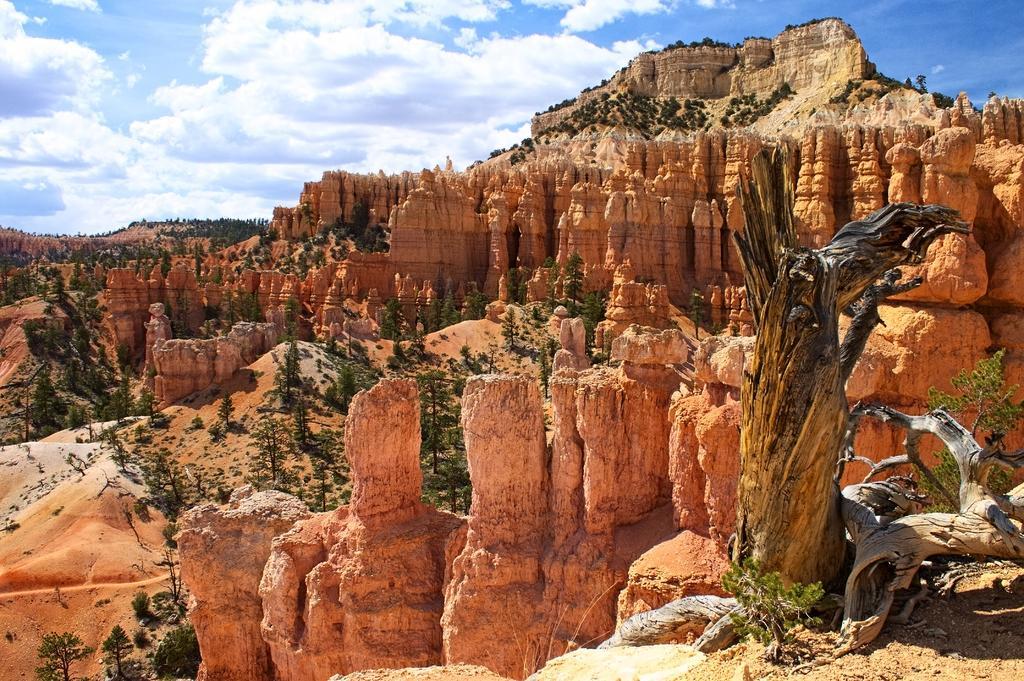How would you summarize this image in a sentence or two? This image consists of grass, plants, trees, tree trunks, mountains, pillars, sand and the sky. This image is taken may be during a sunny day. 